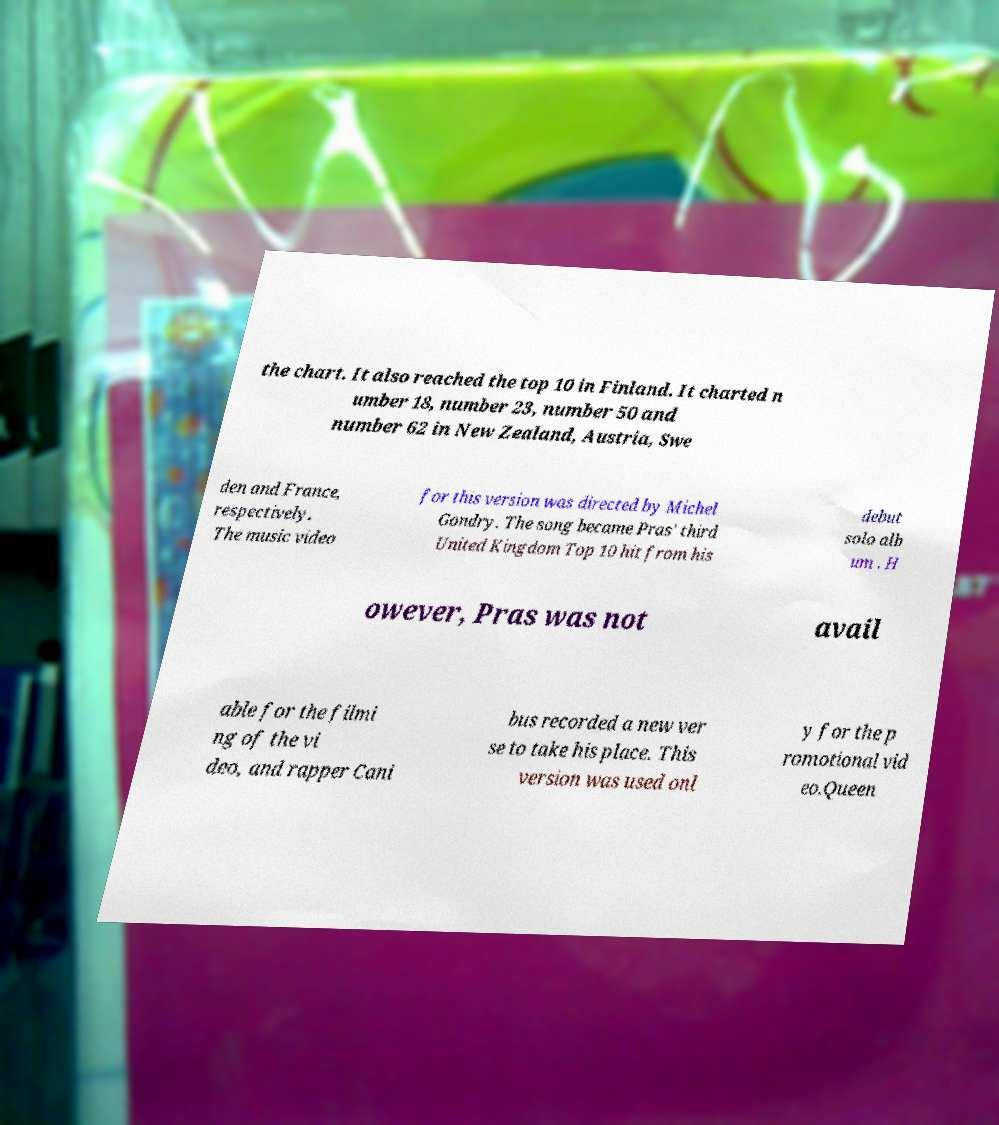Can you accurately transcribe the text from the provided image for me? the chart. It also reached the top 10 in Finland. It charted n umber 18, number 23, number 50 and number 62 in New Zealand, Austria, Swe den and France, respectively. The music video for this version was directed by Michel Gondry. The song became Pras' third United Kingdom Top 10 hit from his debut solo alb um . H owever, Pras was not avail able for the filmi ng of the vi deo, and rapper Cani bus recorded a new ver se to take his place. This version was used onl y for the p romotional vid eo.Queen 